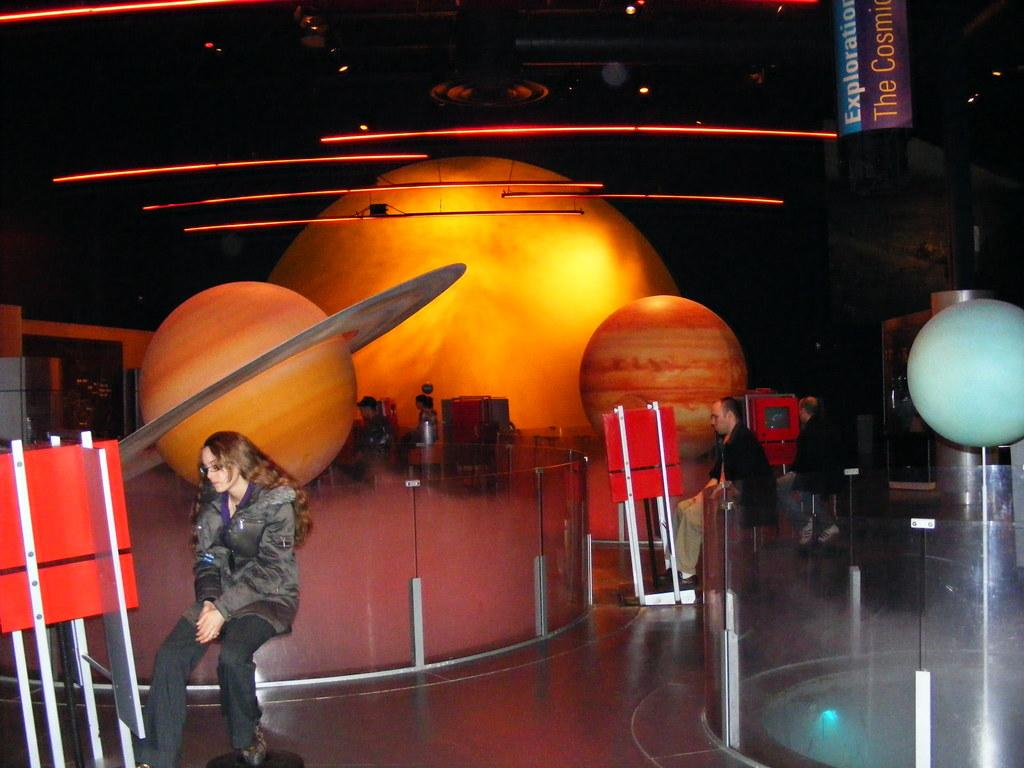What is the main subject on the left side of the image? There is a beautiful girl sitting on the left side of the image. What is the girl wearing in the image? The girl is wearing a coat and trousers. What is the main subject on the right side of the image? There is a man sitting on the right side of the image. What can be seen in the middle of the image? In the middle of the image, there appears to be a representation of a solar system. What type of produce can be seen in the image? There is no produce present in the image. 